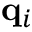Convert formula to latex. <formula><loc_0><loc_0><loc_500><loc_500>q _ { i }</formula> 